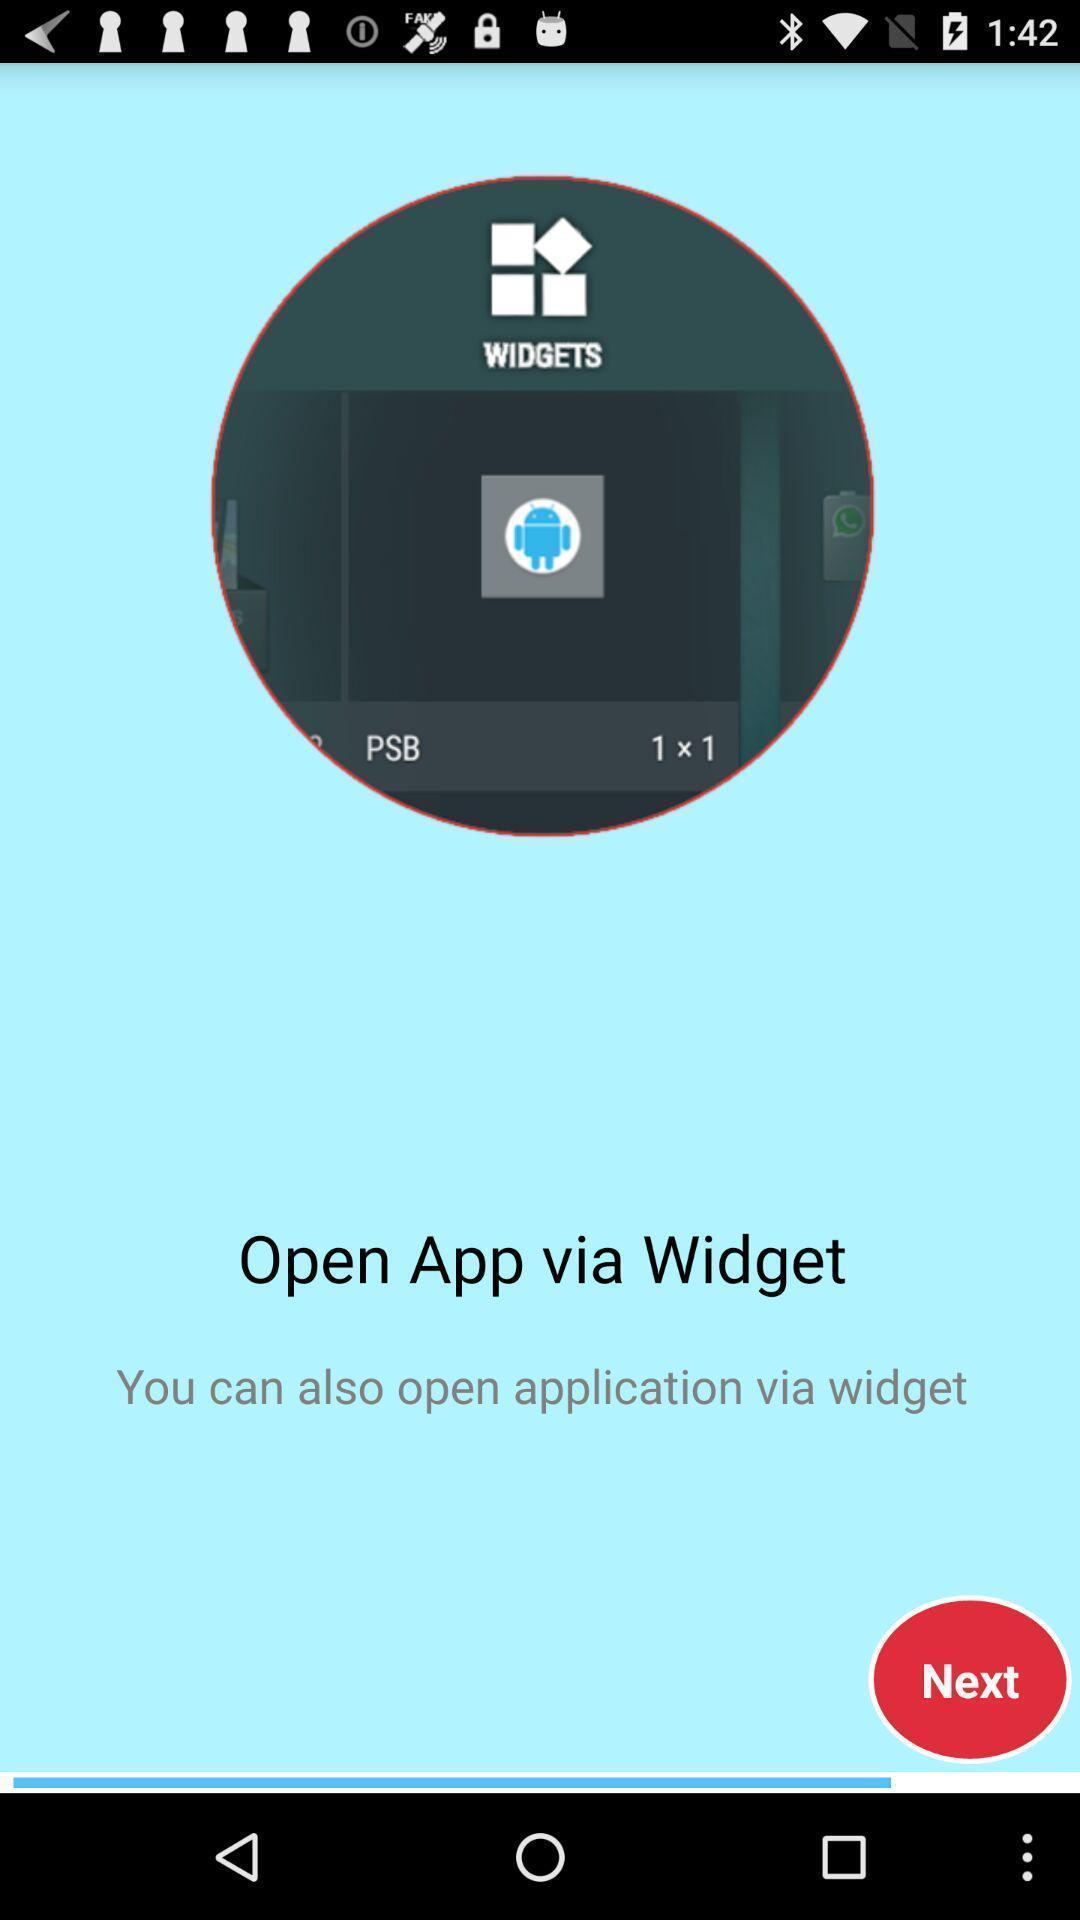What details can you identify in this image? Welcome page of a messaging application. 